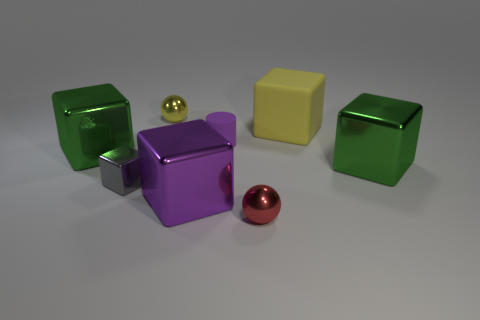What number of gray metal things have the same shape as the big yellow rubber thing?
Ensure brevity in your answer.  1. There is a gray thing that is the same material as the large purple block; what shape is it?
Keep it short and to the point. Cube. How many gray objects are either tiny metal blocks or tiny matte objects?
Give a very brief answer. 1. Are there any gray objects in front of the tiny gray metal block?
Make the answer very short. No. There is a yellow thing left of the red sphere; does it have the same shape as the green metallic object on the right side of the small red sphere?
Provide a short and direct response. No. What material is the tiny thing that is the same shape as the large yellow object?
Provide a succinct answer. Metal. How many cylinders are large matte objects or big purple shiny objects?
Offer a very short reply. 0. How many yellow spheres are the same material as the tiny red ball?
Your response must be concise. 1. Does the tiny ball to the right of the yellow metal ball have the same material as the yellow thing that is left of the large purple shiny block?
Your answer should be compact. Yes. How many tiny yellow balls are right of the large purple shiny cube to the left of the metallic sphere that is on the right side of the tiny purple matte thing?
Your answer should be compact. 0. 